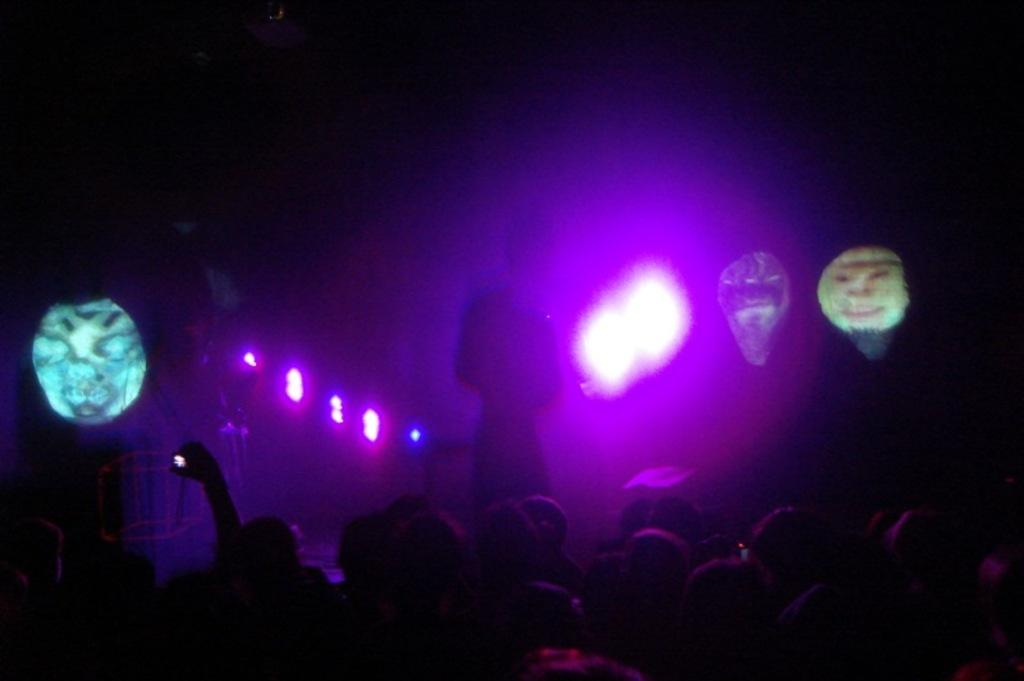What event is taking place in the image? The image appears to depict a concert. What can be seen in the background of the image? There are beautiful lights in the image. Who is on the stage in the image? There is a person on the stage in the image. What is the audience doing in the image? There is a crowd in front of the stage in the image. What type of liquid can be seen dripping from the ceiling in the image? There is no liquid dripping from the ceiling in the image; it depicts a concert with beautiful lights and a performer on stage. 